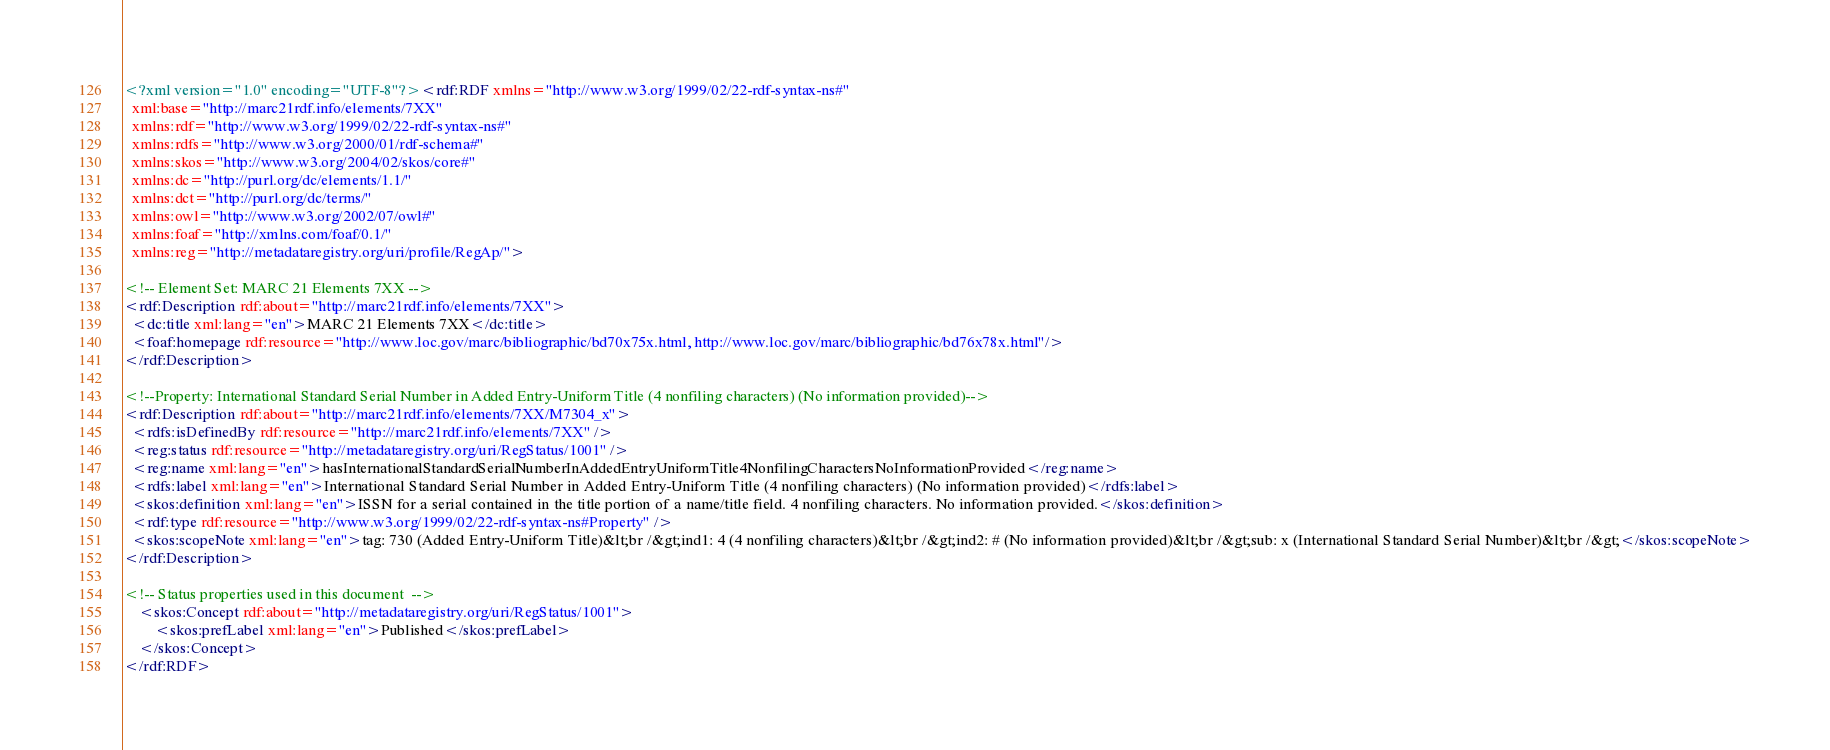<code> <loc_0><loc_0><loc_500><loc_500><_XML_><?xml version="1.0" encoding="UTF-8"?><rdf:RDF xmlns="http://www.w3.org/1999/02/22-rdf-syntax-ns#"
  xml:base="http://marc21rdf.info/elements/7XX"
  xmlns:rdf="http://www.w3.org/1999/02/22-rdf-syntax-ns#"
  xmlns:rdfs="http://www.w3.org/2000/01/rdf-schema#"
  xmlns:skos="http://www.w3.org/2004/02/skos/core#"
  xmlns:dc="http://purl.org/dc/elements/1.1/"
  xmlns:dct="http://purl.org/dc/terms/"
  xmlns:owl="http://www.w3.org/2002/07/owl#"
  xmlns:foaf="http://xmlns.com/foaf/0.1/"
  xmlns:reg="http://metadataregistry.org/uri/profile/RegAp/">

<!-- Element Set: MARC 21 Elements 7XX -->
<rdf:Description rdf:about="http://marc21rdf.info/elements/7XX">
  <dc:title xml:lang="en">MARC 21 Elements 7XX</dc:title>
  <foaf:homepage rdf:resource="http://www.loc.gov/marc/bibliographic/bd70x75x.html, http://www.loc.gov/marc/bibliographic/bd76x78x.html"/>
</rdf:Description>

<!--Property: International Standard Serial Number in Added Entry-Uniform Title (4 nonfiling characters) (No information provided)-->
<rdf:Description rdf:about="http://marc21rdf.info/elements/7XX/M7304_x">
  <rdfs:isDefinedBy rdf:resource="http://marc21rdf.info/elements/7XX" />
  <reg:status rdf:resource="http://metadataregistry.org/uri/RegStatus/1001" />
  <reg:name xml:lang="en">hasInternationalStandardSerialNumberInAddedEntryUniformTitle4NonfilingCharactersNoInformationProvided</reg:name>
  <rdfs:label xml:lang="en">International Standard Serial Number in Added Entry-Uniform Title (4 nonfiling characters) (No information provided)</rdfs:label>
  <skos:definition xml:lang="en">ISSN for a serial contained in the title portion of a name/title field. 4 nonfiling characters. No information provided.</skos:definition>
  <rdf:type rdf:resource="http://www.w3.org/1999/02/22-rdf-syntax-ns#Property" />
  <skos:scopeNote xml:lang="en">tag: 730 (Added Entry-Uniform Title)&lt;br /&gt;ind1: 4 (4 nonfiling characters)&lt;br /&gt;ind2: # (No information provided)&lt;br /&gt;sub: x (International Standard Serial Number)&lt;br /&gt;</skos:scopeNote>
</rdf:Description>

<!-- Status properties used in this document  -->
    <skos:Concept rdf:about="http://metadataregistry.org/uri/RegStatus/1001">
        <skos:prefLabel xml:lang="en">Published</skos:prefLabel>
    </skos:Concept>
</rdf:RDF></code> 